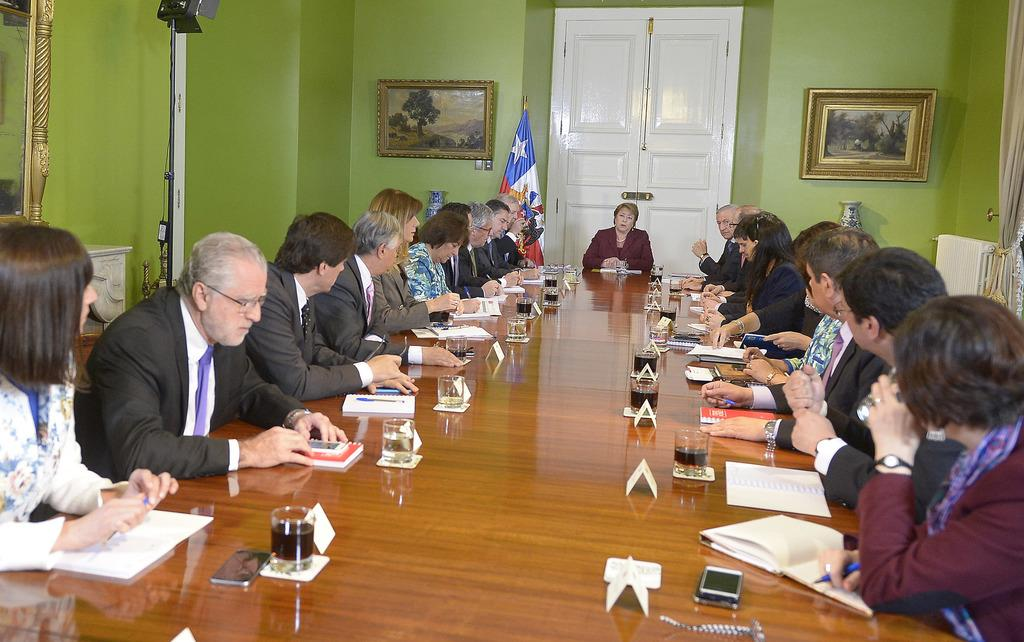What are the people in the image doing? There is a group of people sitting on chairs. What items can be seen on the table in the image? There are books, glasses, a mobile, and a pen on the table. What is visible in the background of the image? There is a door visible in the background. What decorations are present on the walls in the image? There is a flag and a frame on the walls. What type of blood test is being conducted in the image? There is no blood test or any reference to blood in the image. What scientific discovery is being discussed by the group of people in the image? There is no indication of a scientific discussion or discovery in the image. 